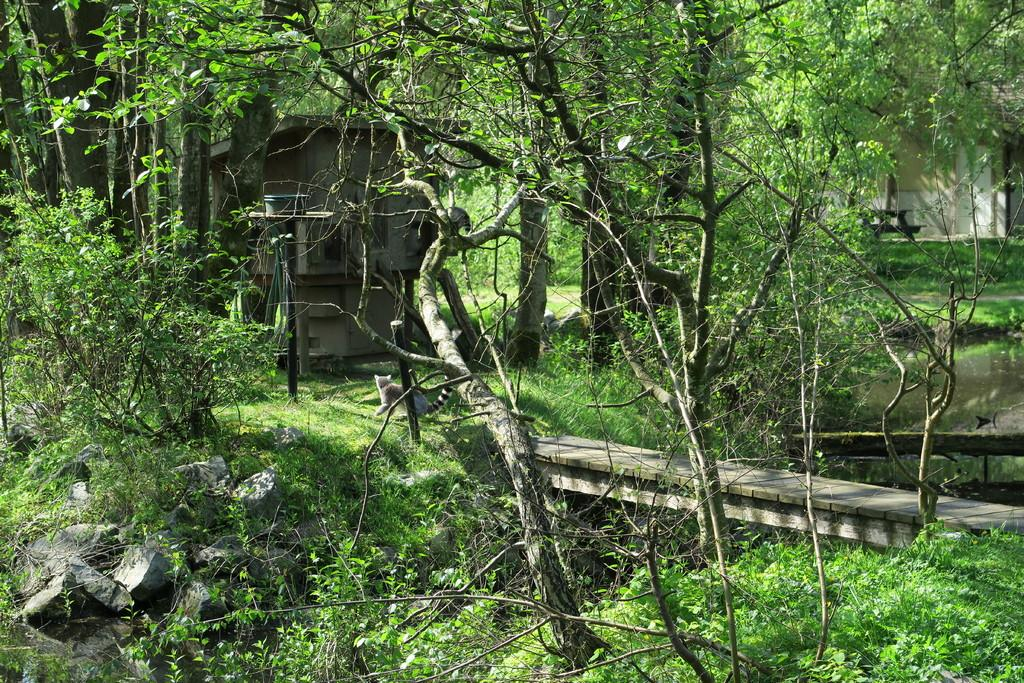What type of natural elements can be seen in the image? There are many trees in the image. Can you describe the structure visible between the trees? There is a building visible between the trees. What other objects are present in the image? Rocks, an animal, a wooden patio, a bench, and a wall are present in the image. How many ants can be seen crawling on the bench in the image? There are no ants visible in the image; only a bench is present. What type of ghost is haunting the building in the image? There is no ghost present in the image; it only features a building, trees, and other objects. 